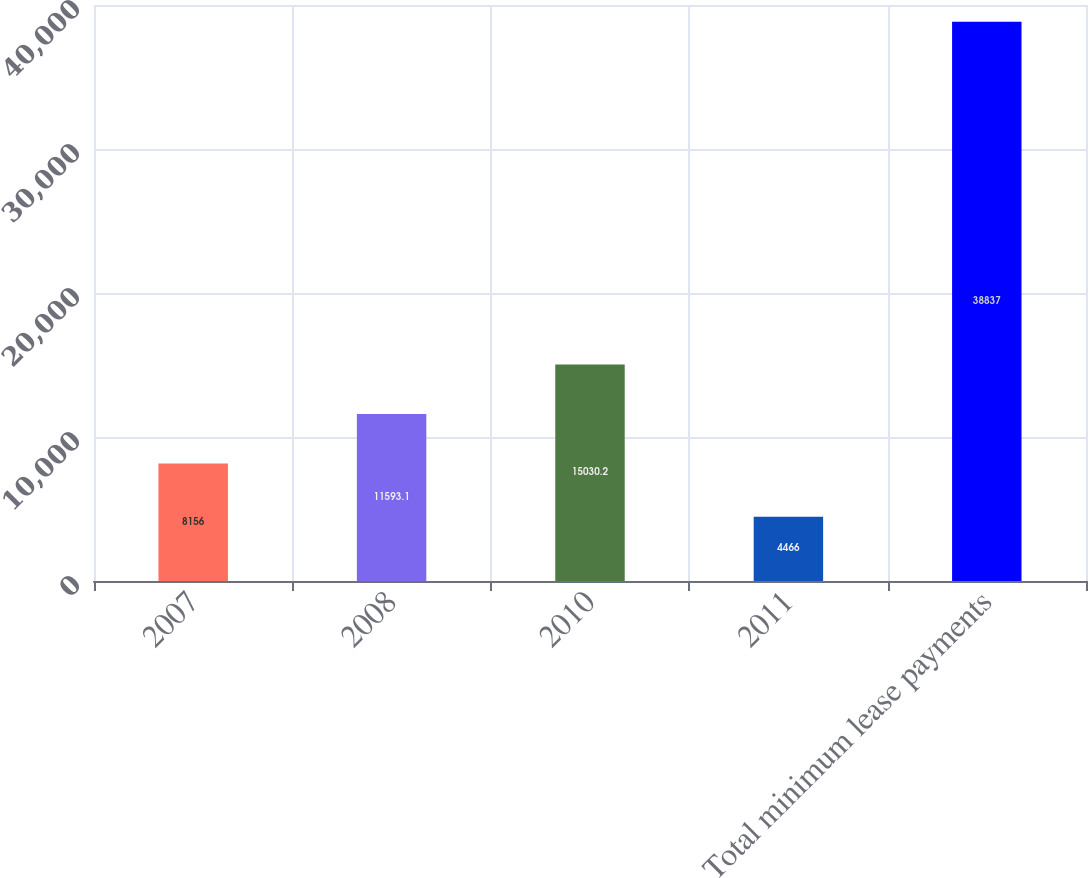<chart> <loc_0><loc_0><loc_500><loc_500><bar_chart><fcel>2007<fcel>2008<fcel>2010<fcel>2011<fcel>Total minimum lease payments<nl><fcel>8156<fcel>11593.1<fcel>15030.2<fcel>4466<fcel>38837<nl></chart> 